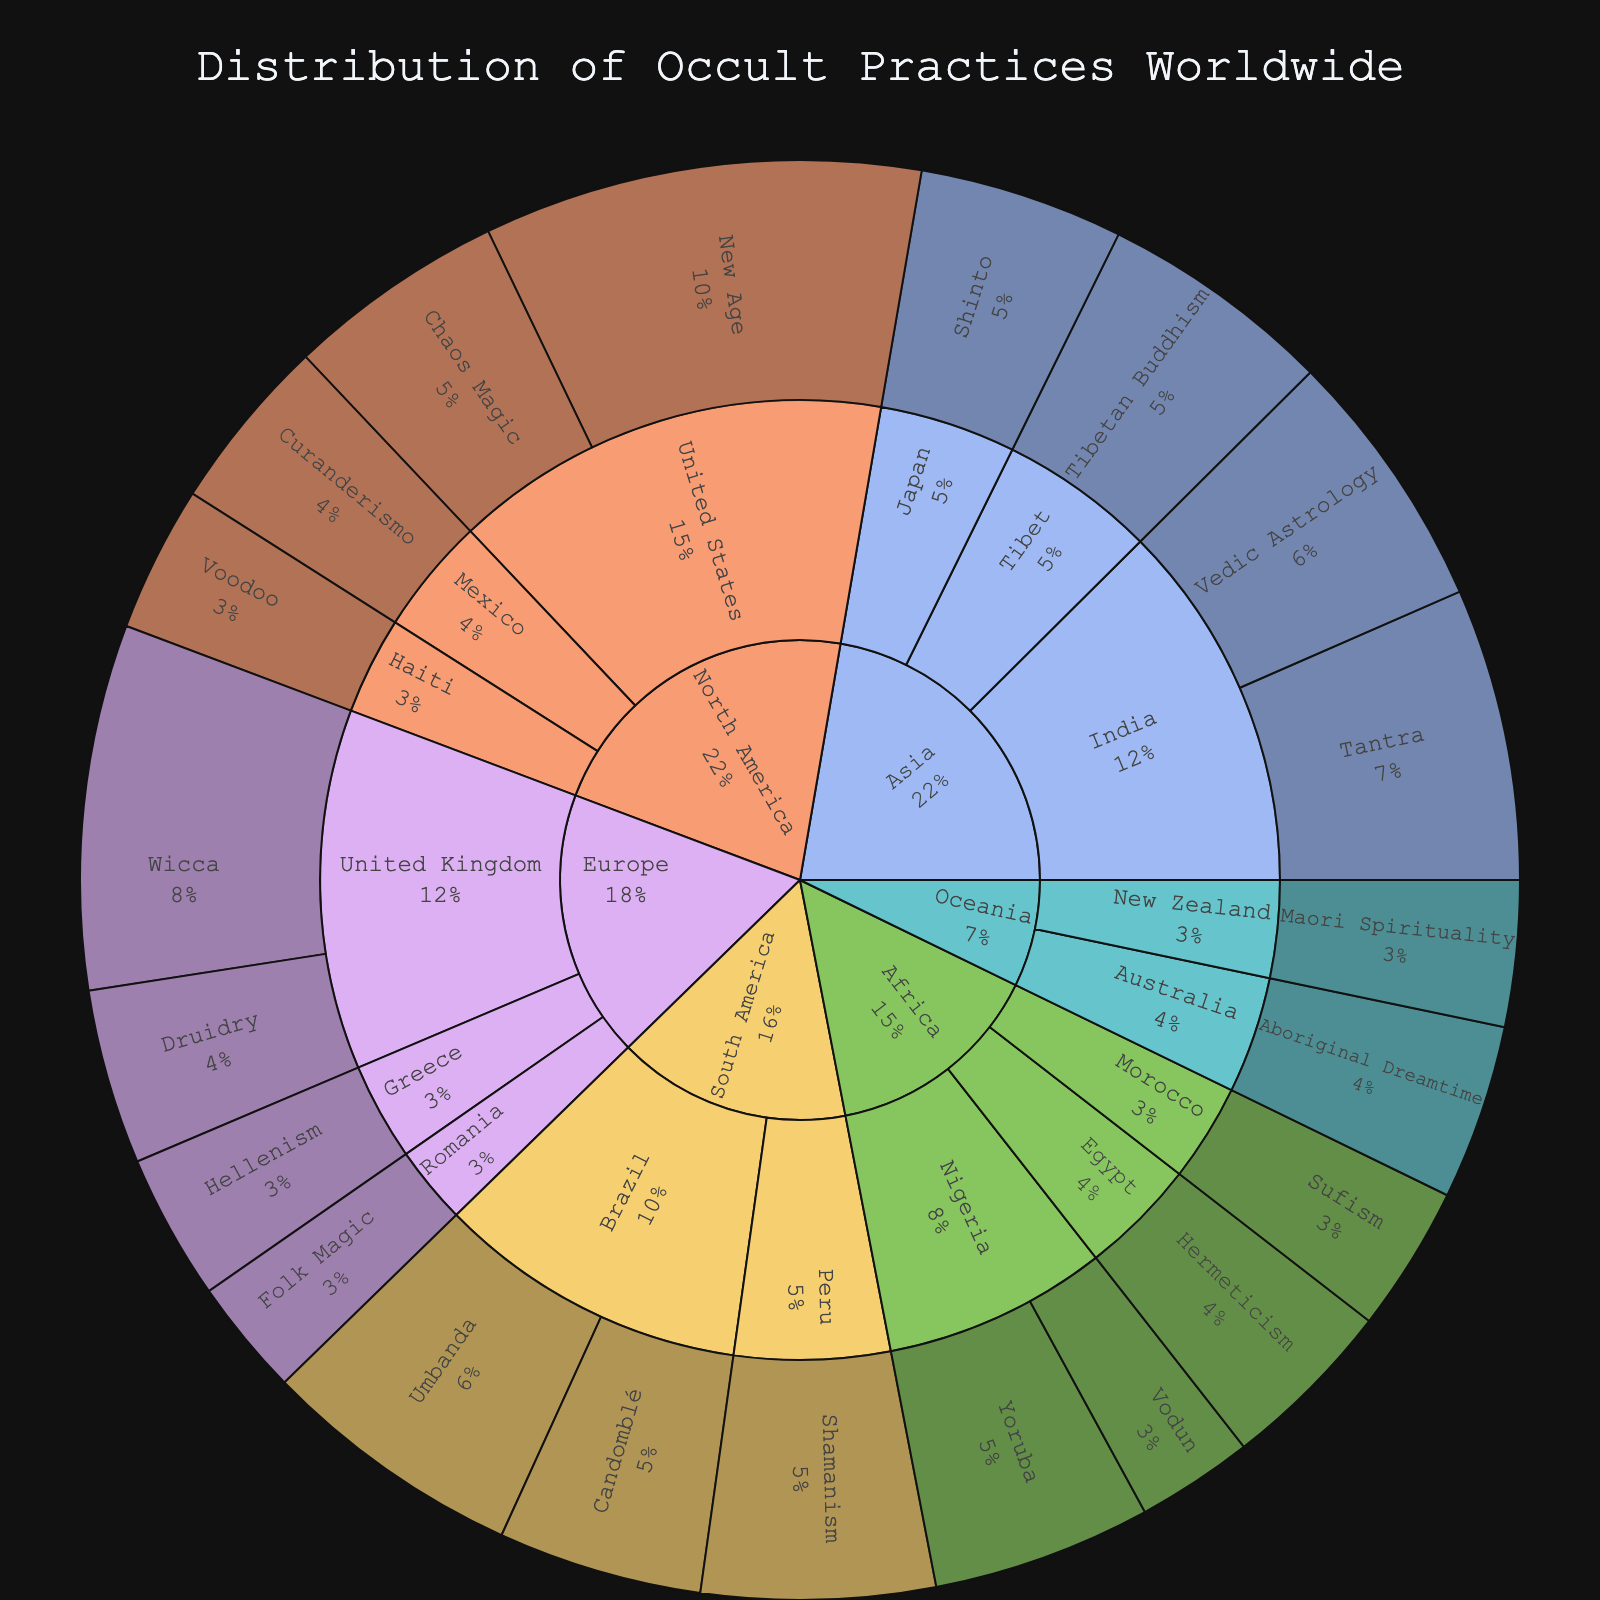What's the title of the figure? The title is usually located at the top of the figure. In this case, it reads, "Distribution of Occult Practices Worldwide".
Answer: Distribution of Occult Practices Worldwide Which continent has the highest value of occult practices? To determine this, sum the values of each practice within each continent. North America has the highest cumulative value with 67 (30 from New Age, 15 from Chaos Magic, 12 from Curanderismo, 10 from Voodoo).
Answer: North America What is the total value of occult practices in Europe? Add up the values of all European countries: 25 (Wicca) + 12 (Druidry) + 10 (Hellenism) + 8 (Folk Magic) = 55.
Answer: 55 In which continent and country is the tradition 'Hermeticism' practiced, and what is its value? Locate 'Hermeticism' in the Sunburst plot and trace back to its continent and country. Hermeticism is in Africa, specifically Egypt, with a value of 12.
Answer: Africa, Egypt, 12 Which country in South America practices 'Shamanism', and what is its value? Locate 'Shamanism' in the Sunburst plot and identify its country under South America. Shamanism is practiced in Peru with a value of 16.
Answer: Peru, 16 Compare the values of 'Vodun' in Nigeria and 'Voodoo' in Haiti. Which has a higher value? Find and compare the values of these traditions in their respective countries. Nigeria's Vodun has a value of 8, while Haiti's Voodoo has a value of 10. Voodoo in Haiti has a higher value.
Answer: Voodoo in Haiti What is the combined value of the practices in India? Sum the values of 'Tantra' and 'Vedic Astrology' under India in Asia. 20 (Tantra) + 18 (Vedic Astrology) = 38.
Answer: 38 Which tradition in Oceania has the lowest value, and what is it? Compare the values of 'Aboriginal Dreamtime' in Australia and 'Maori Spirituality' in New Zealand. Both have similar values.
Answer: Maori Spirituality, 10 What percentage of the total value does 'Wicca' in the United Kingdom represent? First, find the total value of all practices: 312. Then compute the percentage of Wicca's value (25) out of the total: (25 / 312) * 100 ≈ 8.0%.
Answer: 8.0% Which continents have practices with values that total more than 60? Sum the values of practices in each continent and identify those with totals over 60. North America (67) and Asia (68) meet this criterion.
Answer: North America, Asia 